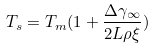Convert formula to latex. <formula><loc_0><loc_0><loc_500><loc_500>T _ { s } = T _ { m } ( 1 + \frac { \Delta \gamma _ { \infty } } { 2 L \rho \xi } )</formula> 